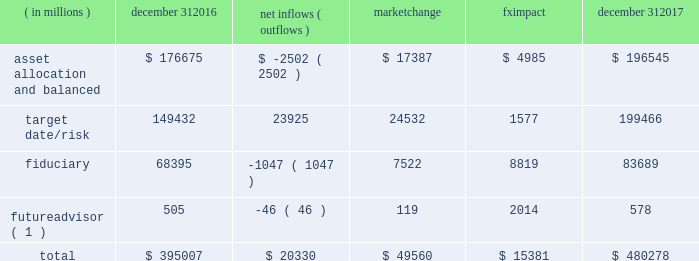Long-term product offerings include alpha-seeking active and index strategies .
Our alpha-seeking active strategies seek to earn attractive returns in excess of a market benchmark or performance hurdle while maintaining an appropriate risk profile , and leverage fundamental research and quantitative models to drive portfolio construction .
In contrast , index strategies seek to closely track the returns of a corresponding index , generally by investing in substantially the same underlying securities within the index or in a subset of those securities selected to approximate a similar risk and return profile of the index .
Index strategies include both our non-etf index products and ishares etfs .
Although many clients use both alpha-seeking active and index strategies , the application of these strategies may differ .
For example , clients may use index products to gain exposure to a market or asset class , or may use a combination of index strategies to target active returns .
In addition , institutional non-etf index assignments tend to be very large ( multi-billion dollars ) and typically reflect low fee rates .
Net flows in institutional index products generally have a small impact on blackrock 2019s revenues and earnings .
Equity year-end 2017 equity aum totaled $ 3.372 trillion , reflecting net inflows of $ 130.1 billion .
Net inflows included $ 174.4 billion into ishares etfs , driven by net inflows into core funds and broad developed and emerging market equities , partially offset by non-etf index and active net outflows of $ 25.7 billion and $ 18.5 billion , respectively .
Blackrock 2019s effective fee rates fluctuate due to changes in aum mix .
Approximately half of blackrock 2019s equity aum is tied to international markets , including emerging markets , which tend to have higher fee rates than u.s .
Equity strategies .
Accordingly , fluctuations in international equity markets , which may not consistently move in tandem with u.s .
Markets , have a greater impact on blackrock 2019s equity revenues and effective fee rate .
Fixed income fixed income aum ended 2017 at $ 1.855 trillion , reflecting net inflows of $ 178.8 billion .
In 2017 , active net inflows of $ 21.5 billion were diversified across fixed income offerings , and included strong inflows into municipal , unconstrained and total return bond funds .
Ishares etfs net inflows of $ 67.5 billion were led by flows into core , corporate and treasury bond funds .
Non-etf index net inflows of $ 89.8 billion were driven by demand for liability-driven investment solutions .
Multi-asset blackrock 2019s multi-asset team manages a variety of balanced funds and bespoke mandates for a diversified client base that leverages our broad investment expertise in global equities , bonds , currencies and commodities , and our extensive risk management capabilities .
Investment solutions might include a combination of long-only portfolios and alternative investments as well as tactical asset allocation overlays .
Component changes in multi-asset aum for 2017 are presented below .
( in millions ) december 31 , net inflows ( outflows ) market change impact december 31 .
( 1 ) futureadvisor amounts do not include aum held in ishares etfs .
Multi-asset net inflows reflected ongoing institutional demand for our solutions-based advice with $ 18.9 billion of net inflows coming from institutional clients .
Defined contribution plans of institutional clients remained a significant driver of flows , and contributed $ 20.8 billion to institutional multi-asset net inflows in 2017 , primarily into target date and target risk product offerings .
Retail net inflows of $ 1.1 billion reflected demand for our multi-asset income fund family , which raised $ 5.8 billion in 2017 .
The company 2019s multi-asset strategies include the following : 2022 asset allocation and balanced products represented 41% ( 41 % ) of multi-asset aum at year-end .
These strategies combine equity , fixed income and alternative components for investors seeking a tailored solution relative to a specific benchmark and within a risk budget .
In certain cases , these strategies seek to minimize downside risk through diversification , derivatives strategies and tactical asset allocation decisions .
Flagship products in this category include our global allocation and multi-asset income fund families .
2022 target date and target risk products grew 16% ( 16 % ) organically in 2017 , with net inflows of $ 23.9 billion .
Institutional investors represented 93% ( 93 % ) of target date and target risk aum , with defined contribution plans accounting for 87% ( 87 % ) of aum .
Flows were driven by defined contribution investments in our lifepath offerings .
Lifepath products utilize a proprietary active asset allocation overlay model that seeks to balance risk and return over an investment horizon based on the investor 2019s expected retirement timing .
Underlying investments are primarily index products .
2022 fiduciary management services are complex mandates in which pension plan sponsors or endowments and foundations retain blackrock to assume responsibility for some or all aspects of investment management .
These customized services require strong partnership with the clients 2019 investment staff and trustees in order to tailor investment strategies to meet client-specific risk budgets and return objectives. .
What percent did the multi asset aum increase between 2016 and 2017? 
Computations: ((480278 / 395007) - 1)
Answer: 0.21587. 